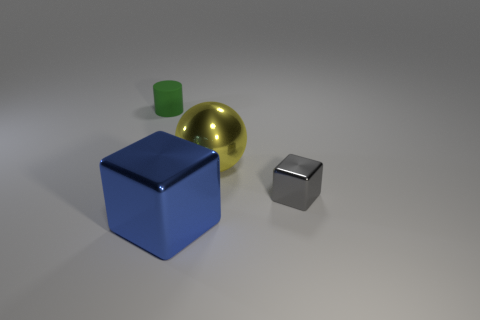Add 1 big green cylinders. How many objects exist? 5 Subtract all spheres. How many objects are left? 3 Subtract all tiny purple shiny things. Subtract all small blocks. How many objects are left? 3 Add 4 small rubber objects. How many small rubber objects are left? 5 Add 2 big blue metallic objects. How many big blue metallic objects exist? 3 Subtract 1 gray blocks. How many objects are left? 3 